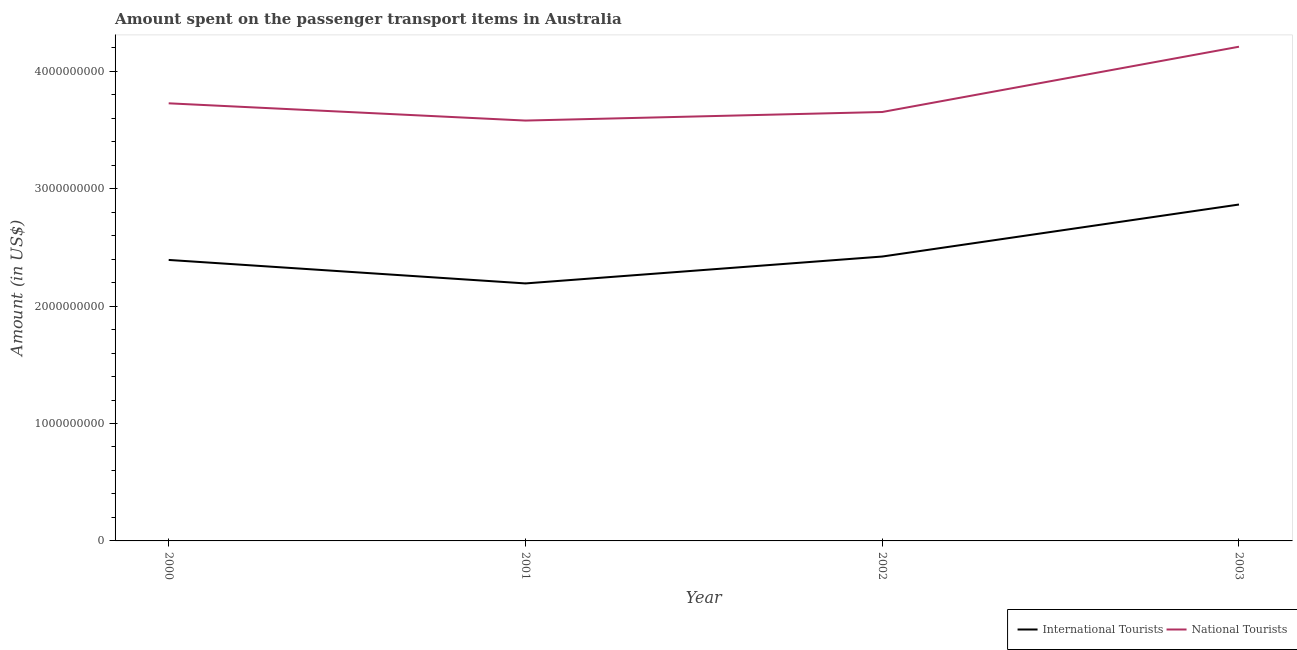How many different coloured lines are there?
Provide a short and direct response. 2. Does the line corresponding to amount spent on transport items of international tourists intersect with the line corresponding to amount spent on transport items of national tourists?
Give a very brief answer. No. What is the amount spent on transport items of national tourists in 2003?
Keep it short and to the point. 4.21e+09. Across all years, what is the maximum amount spent on transport items of international tourists?
Keep it short and to the point. 2.86e+09. Across all years, what is the minimum amount spent on transport items of international tourists?
Your answer should be very brief. 2.19e+09. In which year was the amount spent on transport items of international tourists minimum?
Your answer should be compact. 2001. What is the total amount spent on transport items of international tourists in the graph?
Your answer should be compact. 9.87e+09. What is the difference between the amount spent on transport items of international tourists in 2000 and that in 2002?
Ensure brevity in your answer.  -2.90e+07. What is the difference between the amount spent on transport items of national tourists in 2000 and the amount spent on transport items of international tourists in 2001?
Your response must be concise. 1.53e+09. What is the average amount spent on transport items of national tourists per year?
Keep it short and to the point. 3.79e+09. In the year 2002, what is the difference between the amount spent on transport items of international tourists and amount spent on transport items of national tourists?
Provide a succinct answer. -1.23e+09. In how many years, is the amount spent on transport items of national tourists greater than 200000000 US$?
Ensure brevity in your answer.  4. What is the ratio of the amount spent on transport items of national tourists in 2000 to that in 2003?
Give a very brief answer. 0.89. Is the difference between the amount spent on transport items of international tourists in 2000 and 2002 greater than the difference between the amount spent on transport items of national tourists in 2000 and 2002?
Give a very brief answer. No. What is the difference between the highest and the second highest amount spent on transport items of international tourists?
Keep it short and to the point. 4.43e+08. What is the difference between the highest and the lowest amount spent on transport items of national tourists?
Give a very brief answer. 6.29e+08. In how many years, is the amount spent on transport items of international tourists greater than the average amount spent on transport items of international tourists taken over all years?
Provide a succinct answer. 1. Does the amount spent on transport items of international tourists monotonically increase over the years?
Provide a short and direct response. No. Is the amount spent on transport items of international tourists strictly greater than the amount spent on transport items of national tourists over the years?
Ensure brevity in your answer.  No. How many years are there in the graph?
Keep it short and to the point. 4. What is the difference between two consecutive major ticks on the Y-axis?
Your answer should be compact. 1.00e+09. Are the values on the major ticks of Y-axis written in scientific E-notation?
Provide a short and direct response. No. Does the graph contain grids?
Give a very brief answer. No. Where does the legend appear in the graph?
Make the answer very short. Bottom right. How many legend labels are there?
Your answer should be very brief. 2. How are the legend labels stacked?
Make the answer very short. Horizontal. What is the title of the graph?
Offer a very short reply. Amount spent on the passenger transport items in Australia. What is the Amount (in US$) in International Tourists in 2000?
Keep it short and to the point. 2.39e+09. What is the Amount (in US$) in National Tourists in 2000?
Ensure brevity in your answer.  3.73e+09. What is the Amount (in US$) of International Tourists in 2001?
Keep it short and to the point. 2.19e+09. What is the Amount (in US$) of National Tourists in 2001?
Keep it short and to the point. 3.58e+09. What is the Amount (in US$) of International Tourists in 2002?
Provide a short and direct response. 2.42e+09. What is the Amount (in US$) of National Tourists in 2002?
Give a very brief answer. 3.65e+09. What is the Amount (in US$) in International Tourists in 2003?
Give a very brief answer. 2.86e+09. What is the Amount (in US$) of National Tourists in 2003?
Keep it short and to the point. 4.21e+09. Across all years, what is the maximum Amount (in US$) of International Tourists?
Your answer should be compact. 2.86e+09. Across all years, what is the maximum Amount (in US$) in National Tourists?
Provide a succinct answer. 4.21e+09. Across all years, what is the minimum Amount (in US$) of International Tourists?
Your answer should be compact. 2.19e+09. Across all years, what is the minimum Amount (in US$) in National Tourists?
Provide a short and direct response. 3.58e+09. What is the total Amount (in US$) of International Tourists in the graph?
Provide a succinct answer. 9.87e+09. What is the total Amount (in US$) of National Tourists in the graph?
Ensure brevity in your answer.  1.52e+1. What is the difference between the Amount (in US$) of International Tourists in 2000 and that in 2001?
Keep it short and to the point. 2.00e+08. What is the difference between the Amount (in US$) in National Tourists in 2000 and that in 2001?
Keep it short and to the point. 1.47e+08. What is the difference between the Amount (in US$) of International Tourists in 2000 and that in 2002?
Your answer should be very brief. -2.90e+07. What is the difference between the Amount (in US$) of National Tourists in 2000 and that in 2002?
Make the answer very short. 7.40e+07. What is the difference between the Amount (in US$) of International Tourists in 2000 and that in 2003?
Ensure brevity in your answer.  -4.72e+08. What is the difference between the Amount (in US$) in National Tourists in 2000 and that in 2003?
Offer a terse response. -4.82e+08. What is the difference between the Amount (in US$) of International Tourists in 2001 and that in 2002?
Offer a terse response. -2.29e+08. What is the difference between the Amount (in US$) of National Tourists in 2001 and that in 2002?
Provide a succinct answer. -7.30e+07. What is the difference between the Amount (in US$) of International Tourists in 2001 and that in 2003?
Your answer should be very brief. -6.72e+08. What is the difference between the Amount (in US$) in National Tourists in 2001 and that in 2003?
Provide a succinct answer. -6.29e+08. What is the difference between the Amount (in US$) of International Tourists in 2002 and that in 2003?
Keep it short and to the point. -4.43e+08. What is the difference between the Amount (in US$) of National Tourists in 2002 and that in 2003?
Give a very brief answer. -5.56e+08. What is the difference between the Amount (in US$) of International Tourists in 2000 and the Amount (in US$) of National Tourists in 2001?
Provide a succinct answer. -1.19e+09. What is the difference between the Amount (in US$) in International Tourists in 2000 and the Amount (in US$) in National Tourists in 2002?
Offer a terse response. -1.26e+09. What is the difference between the Amount (in US$) in International Tourists in 2000 and the Amount (in US$) in National Tourists in 2003?
Ensure brevity in your answer.  -1.82e+09. What is the difference between the Amount (in US$) of International Tourists in 2001 and the Amount (in US$) of National Tourists in 2002?
Give a very brief answer. -1.46e+09. What is the difference between the Amount (in US$) of International Tourists in 2001 and the Amount (in US$) of National Tourists in 2003?
Make the answer very short. -2.02e+09. What is the difference between the Amount (in US$) of International Tourists in 2002 and the Amount (in US$) of National Tourists in 2003?
Provide a succinct answer. -1.79e+09. What is the average Amount (in US$) of International Tourists per year?
Your answer should be very brief. 2.47e+09. What is the average Amount (in US$) of National Tourists per year?
Make the answer very short. 3.79e+09. In the year 2000, what is the difference between the Amount (in US$) of International Tourists and Amount (in US$) of National Tourists?
Offer a very short reply. -1.33e+09. In the year 2001, what is the difference between the Amount (in US$) of International Tourists and Amount (in US$) of National Tourists?
Offer a very short reply. -1.39e+09. In the year 2002, what is the difference between the Amount (in US$) in International Tourists and Amount (in US$) in National Tourists?
Provide a short and direct response. -1.23e+09. In the year 2003, what is the difference between the Amount (in US$) in International Tourists and Amount (in US$) in National Tourists?
Offer a very short reply. -1.34e+09. What is the ratio of the Amount (in US$) of International Tourists in 2000 to that in 2001?
Ensure brevity in your answer.  1.09. What is the ratio of the Amount (in US$) in National Tourists in 2000 to that in 2001?
Ensure brevity in your answer.  1.04. What is the ratio of the Amount (in US$) in National Tourists in 2000 to that in 2002?
Give a very brief answer. 1.02. What is the ratio of the Amount (in US$) in International Tourists in 2000 to that in 2003?
Provide a short and direct response. 0.84. What is the ratio of the Amount (in US$) of National Tourists in 2000 to that in 2003?
Make the answer very short. 0.89. What is the ratio of the Amount (in US$) in International Tourists in 2001 to that in 2002?
Provide a short and direct response. 0.91. What is the ratio of the Amount (in US$) in National Tourists in 2001 to that in 2002?
Your answer should be very brief. 0.98. What is the ratio of the Amount (in US$) of International Tourists in 2001 to that in 2003?
Make the answer very short. 0.77. What is the ratio of the Amount (in US$) of National Tourists in 2001 to that in 2003?
Offer a terse response. 0.85. What is the ratio of the Amount (in US$) in International Tourists in 2002 to that in 2003?
Keep it short and to the point. 0.85. What is the ratio of the Amount (in US$) in National Tourists in 2002 to that in 2003?
Your answer should be very brief. 0.87. What is the difference between the highest and the second highest Amount (in US$) of International Tourists?
Provide a succinct answer. 4.43e+08. What is the difference between the highest and the second highest Amount (in US$) in National Tourists?
Give a very brief answer. 4.82e+08. What is the difference between the highest and the lowest Amount (in US$) of International Tourists?
Your answer should be compact. 6.72e+08. What is the difference between the highest and the lowest Amount (in US$) of National Tourists?
Keep it short and to the point. 6.29e+08. 